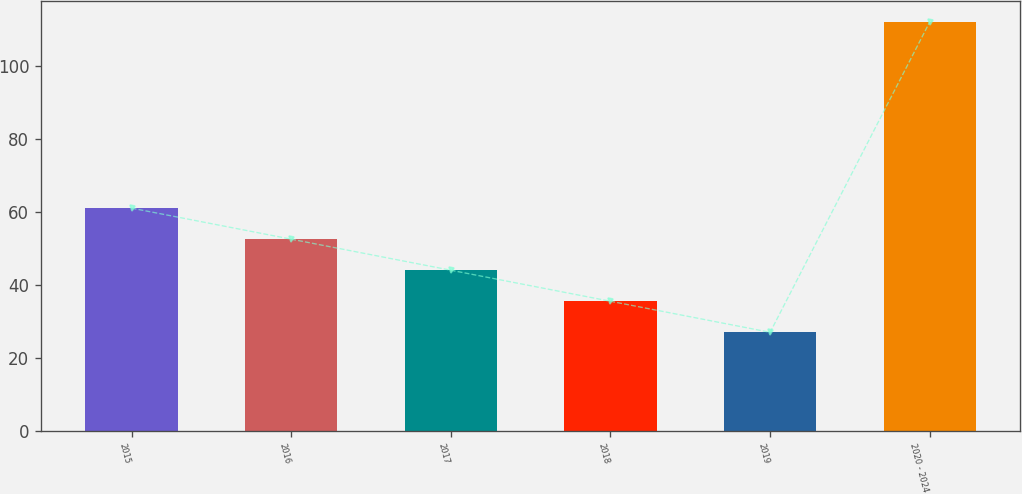Convert chart to OTSL. <chart><loc_0><loc_0><loc_500><loc_500><bar_chart><fcel>2015<fcel>2016<fcel>2017<fcel>2018<fcel>2019<fcel>2020 - 2024<nl><fcel>61<fcel>52.5<fcel>44<fcel>35.5<fcel>27<fcel>112<nl></chart> 